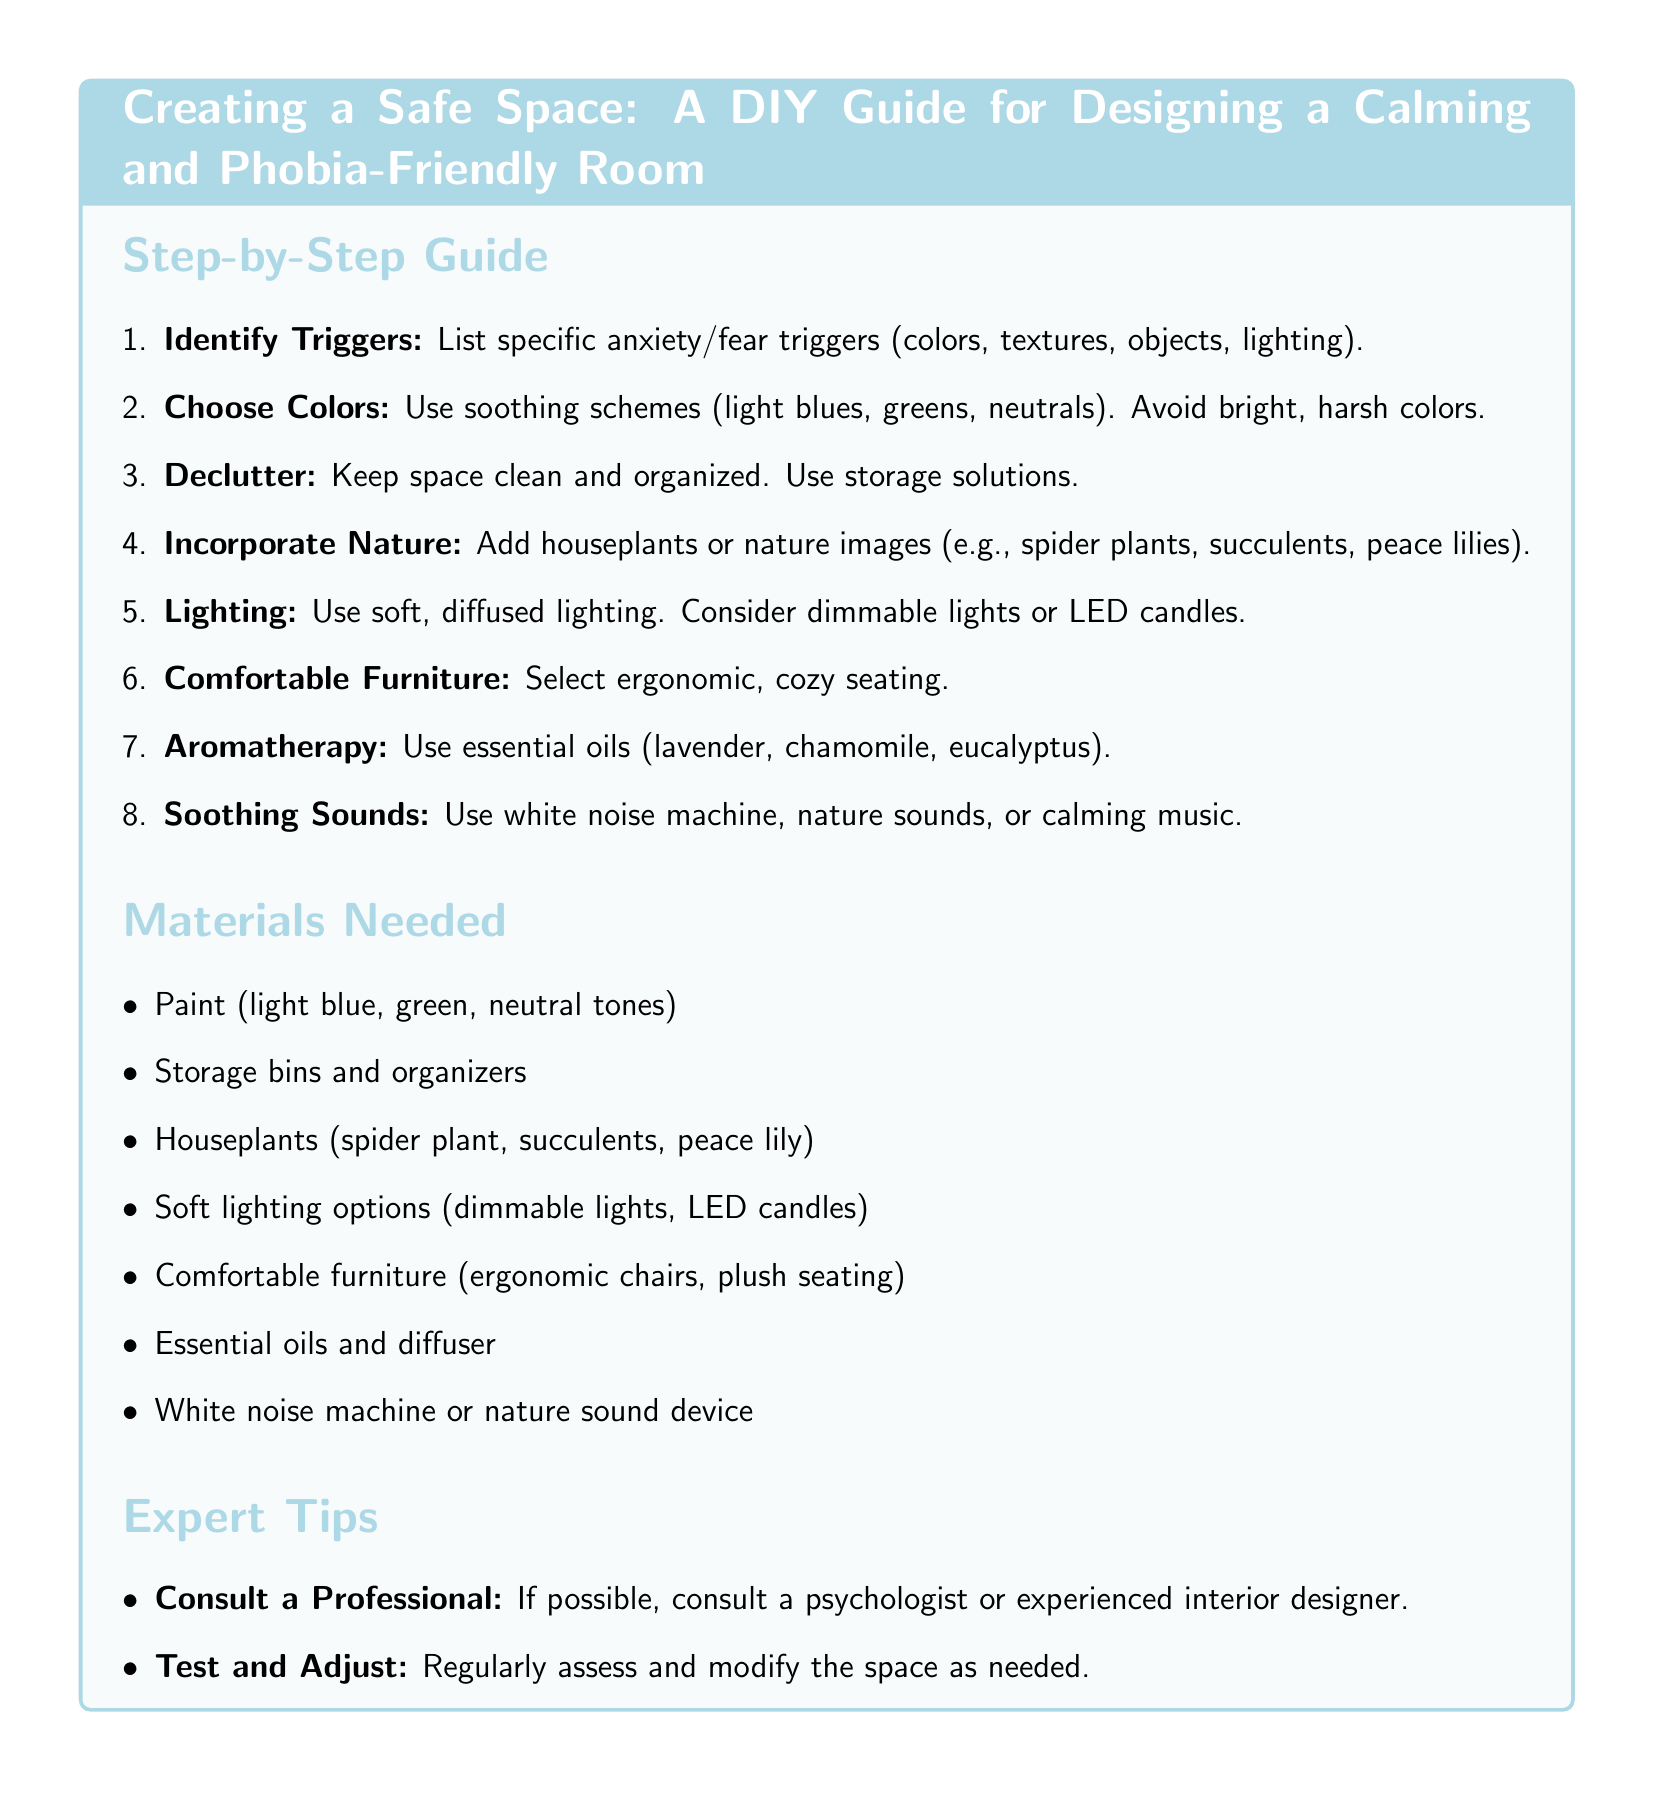What is the first step in creating a safe space? The first step listed in the guide is to identify triggers such as colors, textures, objects, or lighting.
Answer: Identify Triggers Which colors should be avoided when designing this space? The guide recommends avoiding bright, harsh colors in favor of soothing schemes.
Answer: Bright, harsh colors What type of furniture is suggested for the room? The document specifies selecting ergonomic, cozy seating to enhance comfort in the space.
Answer: Comfortable furniture Name one type of plant recommended for incorporation into the space. The guide lists several plants, including the spider plant, as good options for creating a calming atmosphere.
Answer: Spider plant What should be used to create a calming aroma? The document mentions using essential oils such as lavender, chamomile, and eucalyptus for aromatherapy.
Answer: Essential oils How many expert tips are provided in the document? There are two specific expert tips at the end of the recipe card.
Answer: Two What is suggested for lighting in the calming room? The guide recommends using soft, diffused lighting and considering dimmable lights or LED candles.
Answer: Soft, diffused lighting What is advised regarding the assessment of the room? The document advises to regularly assess and modify the space as needed for continued effectiveness.
Answer: Test and Adjust 